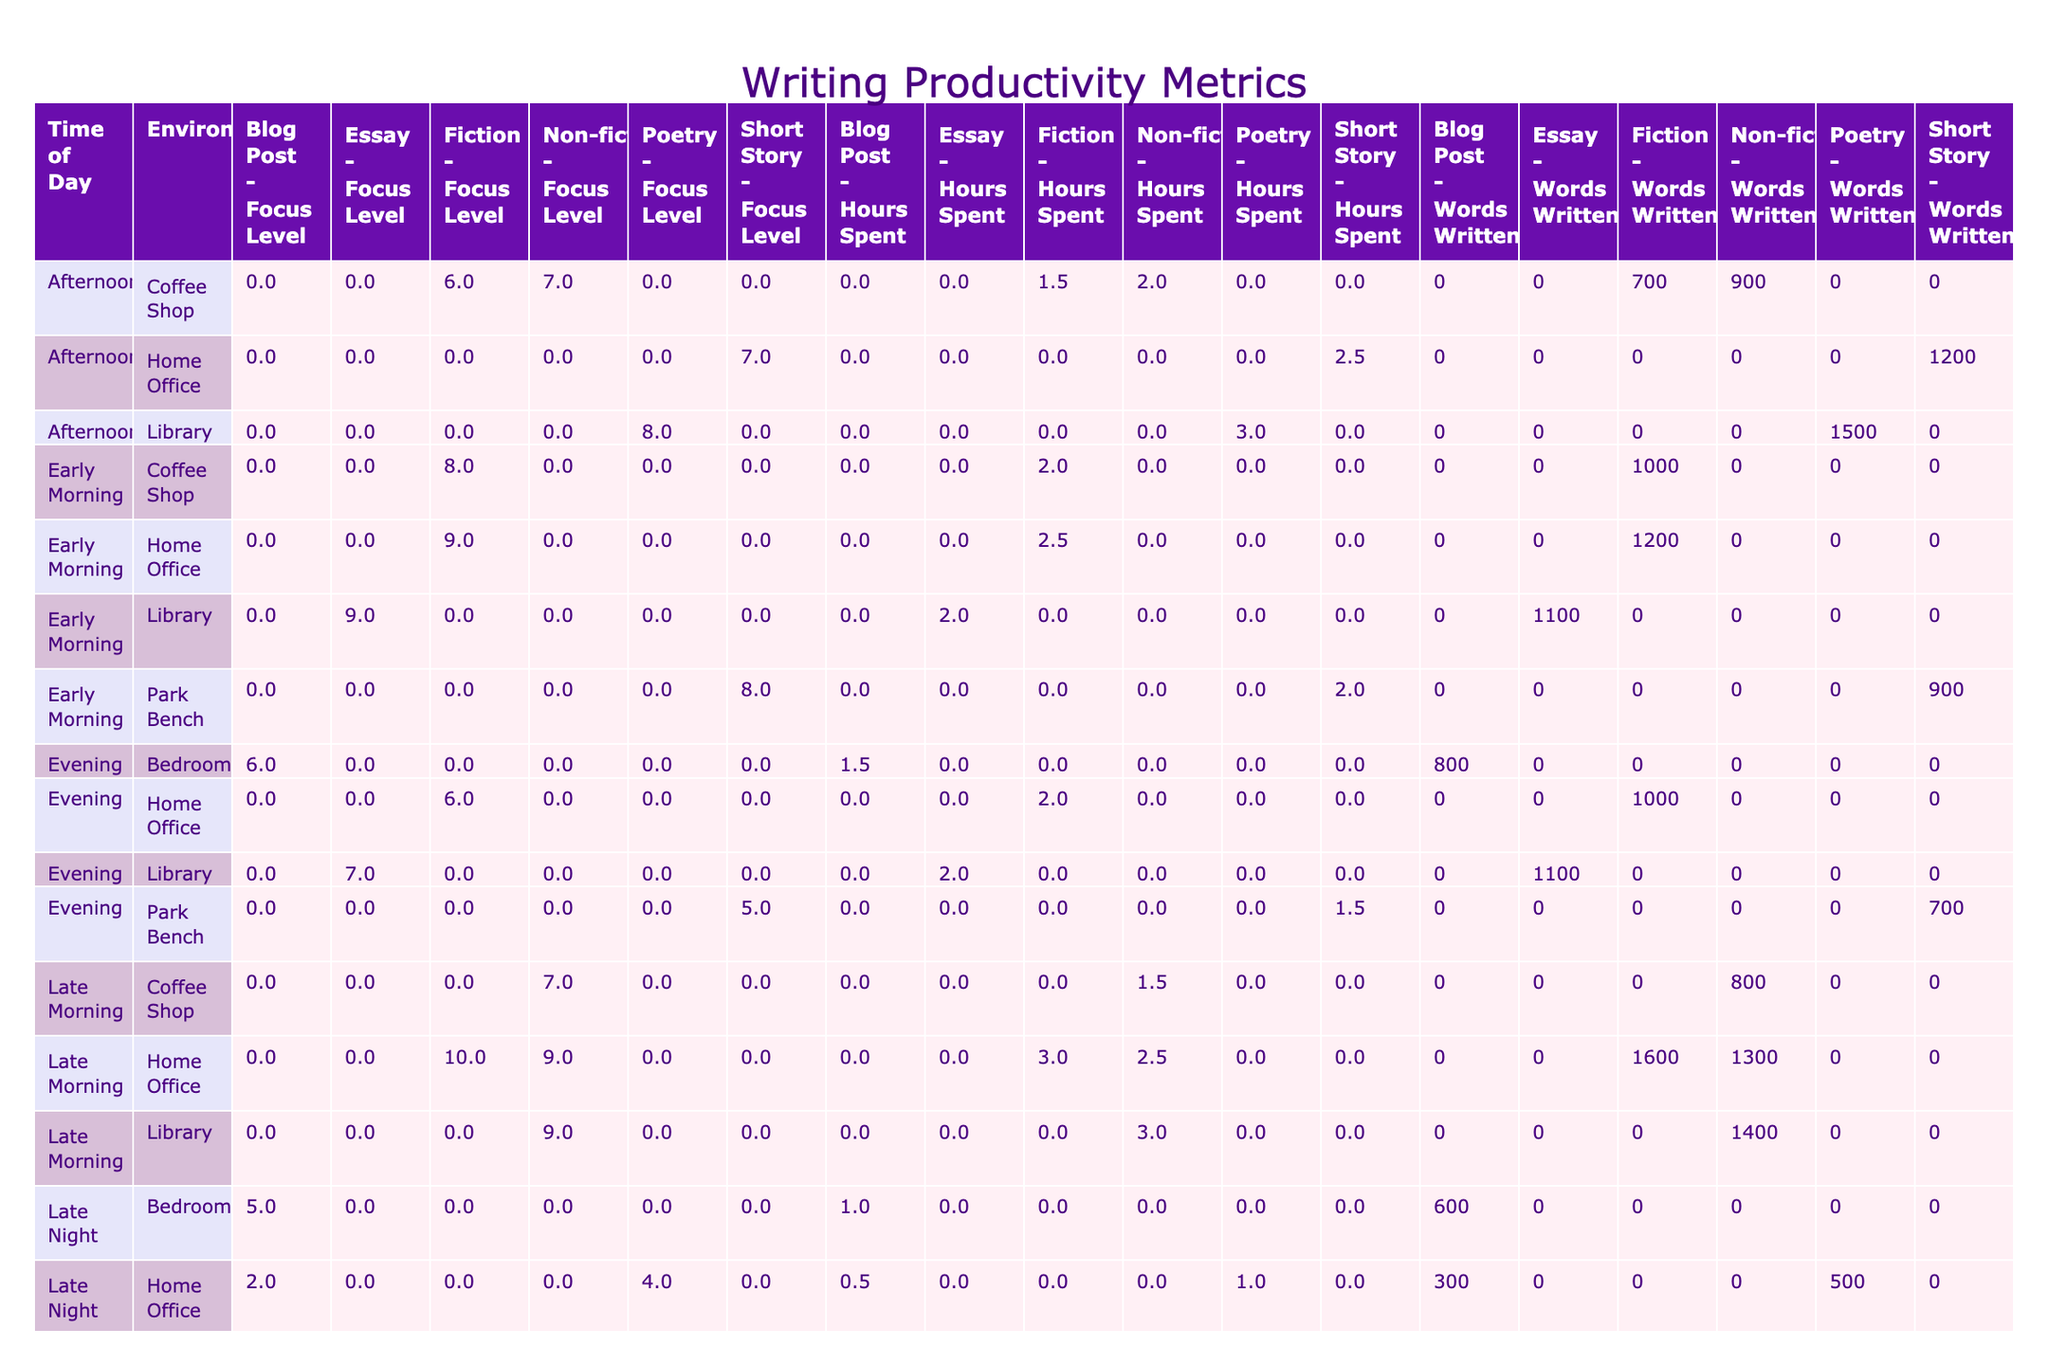What is the total number of words written in the Early Morning across all environments? Looking at the table, the total number of words written in Early Morning is sum(1200 + 900 + 1000 + 1100) = 4200 words for the four entries found under Early Morning.
Answer: 4200 Which environment had the highest focus level for Fiction? The focus levels for Fiction are 9 in Home Office (Monday), 6 in Home Office (Thursday), and 7 in Coffee Shop (Monday). The highest focus level is 9, occurring in the Home Office on Monday.
Answer: Home Office What is the average number of words written in the Library, considering all genres? The total words written in Library is sum(1500 + 1100 + 1600) = 4200. The number of entries is 3, so the average is 4200 / 3 = 1400.
Answer: 1400 Was the focus level for Blog Posts higher in the Bedroom or the Home Office? The focus level for Blog Posts in the Bedroom is 6 (Sunday) and in the Home Office is 4 (Friday). Since 6 is greater than 4, the focus level for Blog Posts was higher in the Bedroom.
Answer: Yes What is the difference in total hours spent writing between Early Morning and Late Night? The total hours spent in Early Morning is sum(2.5 + 2 + 2 + 2) = 8.5 hours, and in Late Night it is sum(1 + 1 + 0.5 + 1) = 3.5 hours. The difference is 8.5 - 3.5 = 5 hours.
Answer: 5 Which day of the week had the highest total words written across all genres? Counting total words for each day: Monday (1200 + 700 + 400 = 2300), Tuesday (800 + 1100 + 1100 = 3000), Wednesday (1500 + 1600 + 500 = 3600), Thursday (1000 + 1000 + 900 = 2900), Friday (600 + 1400 + 700 = 2700), Saturday (900 + 1200 + 300 = 2400), Sunday (1300 + 800 = 2100). The highest is 3600 on Wednesday.
Answer: Wednesday What is the sum of the focus levels for Non-fiction across all times and environments? The focus levels for Non-fiction are 7 (Tuesday), 9 (Sunday), 9 (Friday), and 7 (Thursday). The sum is 7 + 9 + 9 + 7 = 32.
Answer: 32 